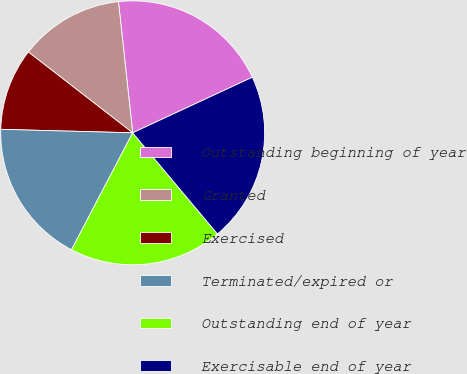Convert chart. <chart><loc_0><loc_0><loc_500><loc_500><pie_chart><fcel>Outstanding beginning of year<fcel>Granted<fcel>Exercised<fcel>Terminated/expired or<fcel>Outstanding end of year<fcel>Exercisable end of year<nl><fcel>19.8%<fcel>12.79%<fcel>10.07%<fcel>17.75%<fcel>18.77%<fcel>20.82%<nl></chart> 